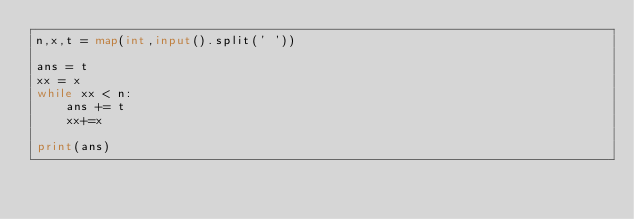Convert code to text. <code><loc_0><loc_0><loc_500><loc_500><_Python_>n,x,t = map(int,input().split(' '))

ans = t
xx = x
while xx < n:
	ans += t
	xx+=x

print(ans)</code> 